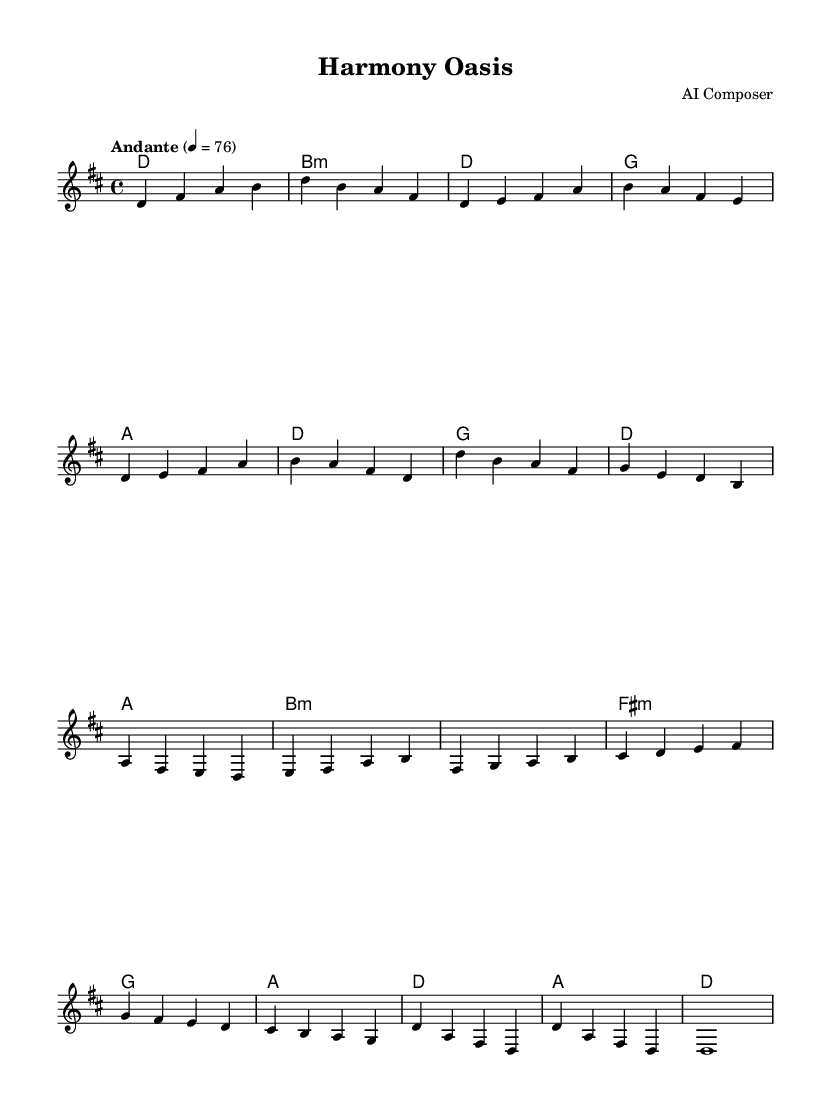What is the key signature of this music? The key signature is D major, which has two sharps: F# and C#.
Answer: D major What is the time signature of this piece? The time signature is four-four, indicating four quarter-note beats per measure.
Answer: 4/4 What is the tempo marking for this composition? The tempo marking is "Andante," which suggests a moderate walking pace.
Answer: Andante How many measures are there in the verse? The verse consists of four measures as indicated in the melody section.
Answer: 4 Which chord appears at the start of the chorus? The first chord in the chorus is G major, followed by D major.
Answer: G How does the harmony change from the verse to the chorus? The harmony shifts from D major in the verse to G major at the start of the chorus, indicating a modulation and change in mood from the verse.
Answer: G to D What is the overall theme of this piece in terms of musical style? The piece incorporates elements of world fusion, promoting cultural diversity and unity through its melodic and harmonic choices.
Answer: World fusion 